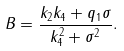Convert formula to latex. <formula><loc_0><loc_0><loc_500><loc_500>B = \frac { k _ { 2 } k _ { 4 } + q _ { 1 } \sigma } { k _ { 4 } ^ { 2 } + \sigma ^ { 2 } } .</formula> 